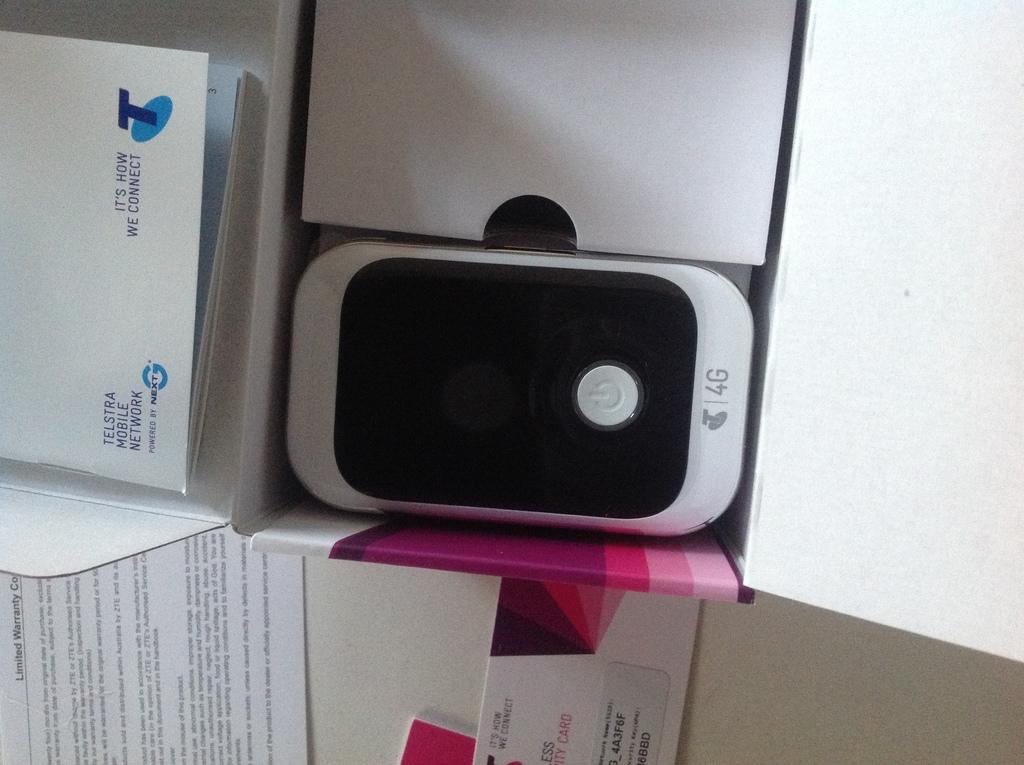<image>
Provide a brief description of the given image. Telstra mobile network 4g white cellphone in a box. 